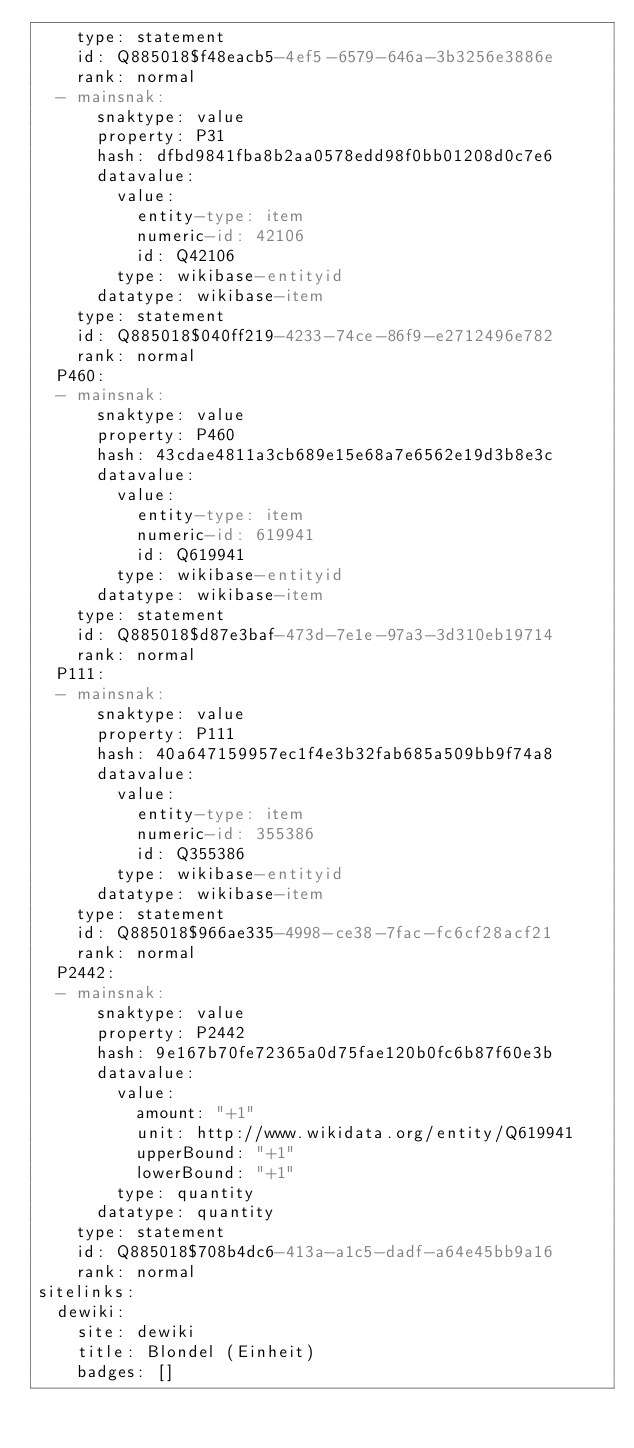Convert code to text. <code><loc_0><loc_0><loc_500><loc_500><_YAML_>    type: statement
    id: Q885018$f48eacb5-4ef5-6579-646a-3b3256e3886e
    rank: normal
  - mainsnak:
      snaktype: value
      property: P31
      hash: dfbd9841fba8b2aa0578edd98f0bb01208d0c7e6
      datavalue:
        value:
          entity-type: item
          numeric-id: 42106
          id: Q42106
        type: wikibase-entityid
      datatype: wikibase-item
    type: statement
    id: Q885018$040ff219-4233-74ce-86f9-e2712496e782
    rank: normal
  P460:
  - mainsnak:
      snaktype: value
      property: P460
      hash: 43cdae4811a3cb689e15e68a7e6562e19d3b8e3c
      datavalue:
        value:
          entity-type: item
          numeric-id: 619941
          id: Q619941
        type: wikibase-entityid
      datatype: wikibase-item
    type: statement
    id: Q885018$d87e3baf-473d-7e1e-97a3-3d310eb19714
    rank: normal
  P111:
  - mainsnak:
      snaktype: value
      property: P111
      hash: 40a647159957ec1f4e3b32fab685a509bb9f74a8
      datavalue:
        value:
          entity-type: item
          numeric-id: 355386
          id: Q355386
        type: wikibase-entityid
      datatype: wikibase-item
    type: statement
    id: Q885018$966ae335-4998-ce38-7fac-fc6cf28acf21
    rank: normal
  P2442:
  - mainsnak:
      snaktype: value
      property: P2442
      hash: 9e167b70fe72365a0d75fae120b0fc6b87f60e3b
      datavalue:
        value:
          amount: "+1"
          unit: http://www.wikidata.org/entity/Q619941
          upperBound: "+1"
          lowerBound: "+1"
        type: quantity
      datatype: quantity
    type: statement
    id: Q885018$708b4dc6-413a-a1c5-dadf-a64e45bb9a16
    rank: normal
sitelinks:
  dewiki:
    site: dewiki
    title: Blondel (Einheit)
    badges: []
</code> 